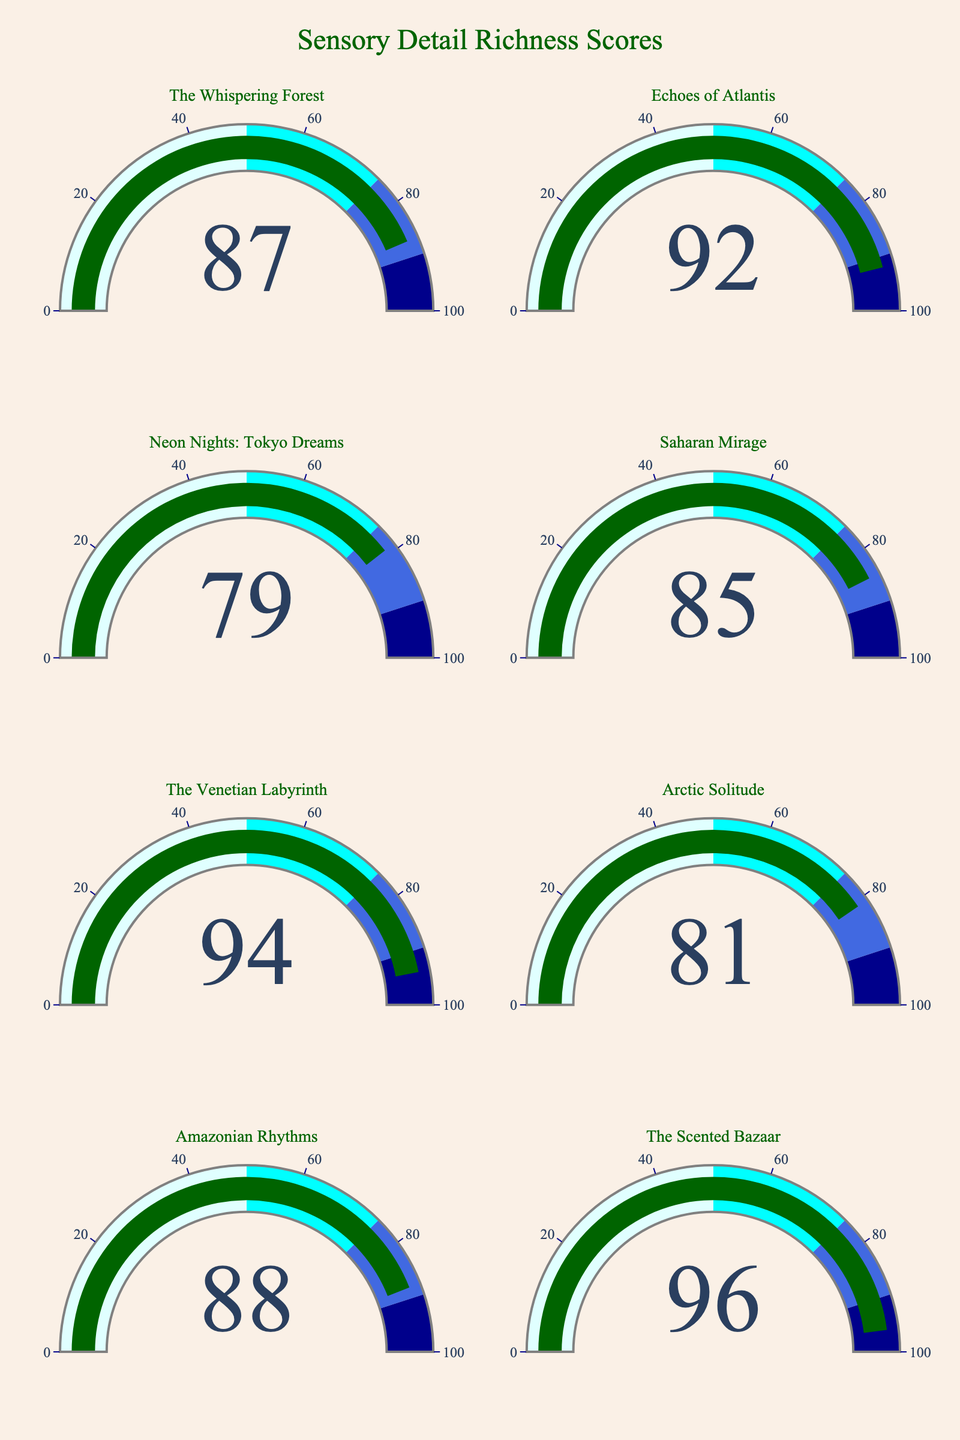What's the Sensory Detail Score of "The Scented Bazaar"? To determine the Sensory Detail Score for "The Scented Bazaar," locate its corresponding gauge on the figure. The number displayed is 96.
Answer: 96 Which book has the highest Sensory Detail Score? Compare the numbers displayed on each gauge. "The Scented Bazaar" has the highest score at 96.
Answer: "The Scented Bazaar" What's the average Sensory Detail Score of the books? Sum all the sensory detail scores: 87 + 92 + 79 + 85 + 94 + 81 + 88 + 96 = 702. Divide by the number of books, which is 8. The average score is 702 / 8 = 87.75.
Answer: 87.75 What is the difference in Sensory Detail Score between "Echoes of Atlantis" and "Neon Nights: Tokyo Dreams"? Find the scores for "Echoes of Atlantis" (92) and "Neon Nights: Tokyo Dreams" (79). Subtract the smaller score from the larger: 92 - 79 = 13.
Answer: 13 Which book has the lowest Sensory Detail Score and what is it? Identify the gauge with the smallest number. "Neon Nights: Tokyo Dreams" has the lowest score at 79.
Answer: "Neon Nights: Tokyo Dreams", 79 How many books have a Sensory Detail Score greater than 85? Count the number of gauges where the score is greater than 85. The books are: "The Whispering Forest" (87), "Echoes of Atlantis" (92), "The Venetian Labyrinth" (94), "Amazonian Rhythms" (88), and "The Scented Bazaar" (96). There are 5 books in total.
Answer: 5 Between "Saharan Mirage" and "Arctic Solitude," which book has a higher Sensory Detail Score and by how much? "Saharan Mirage" has a score of 85, and "Arctic Solitude" has 81. The difference is 85 - 81 = 4. "Saharan Mirage" has a higher score by 4.
Answer: "Saharan Mirage" by 4 What's the range of the Sensory Detail Scores? Calculate the difference between the highest and lowest scores. The highest score is 96 ("The Scented Bazaar") and the lowest is 79 ("Neon Nights: Tokyo Dreams"). The range is 96 - 79 = 17.
Answer: 17 Which book has a Sensory Detail Score closest to 90? Compare the scores to see which is closest to 90. "Echoes of Atlantis" has a score of 92, which is closest to 90 with a difference of 2.
Answer: "Echoes of Atlantis" 